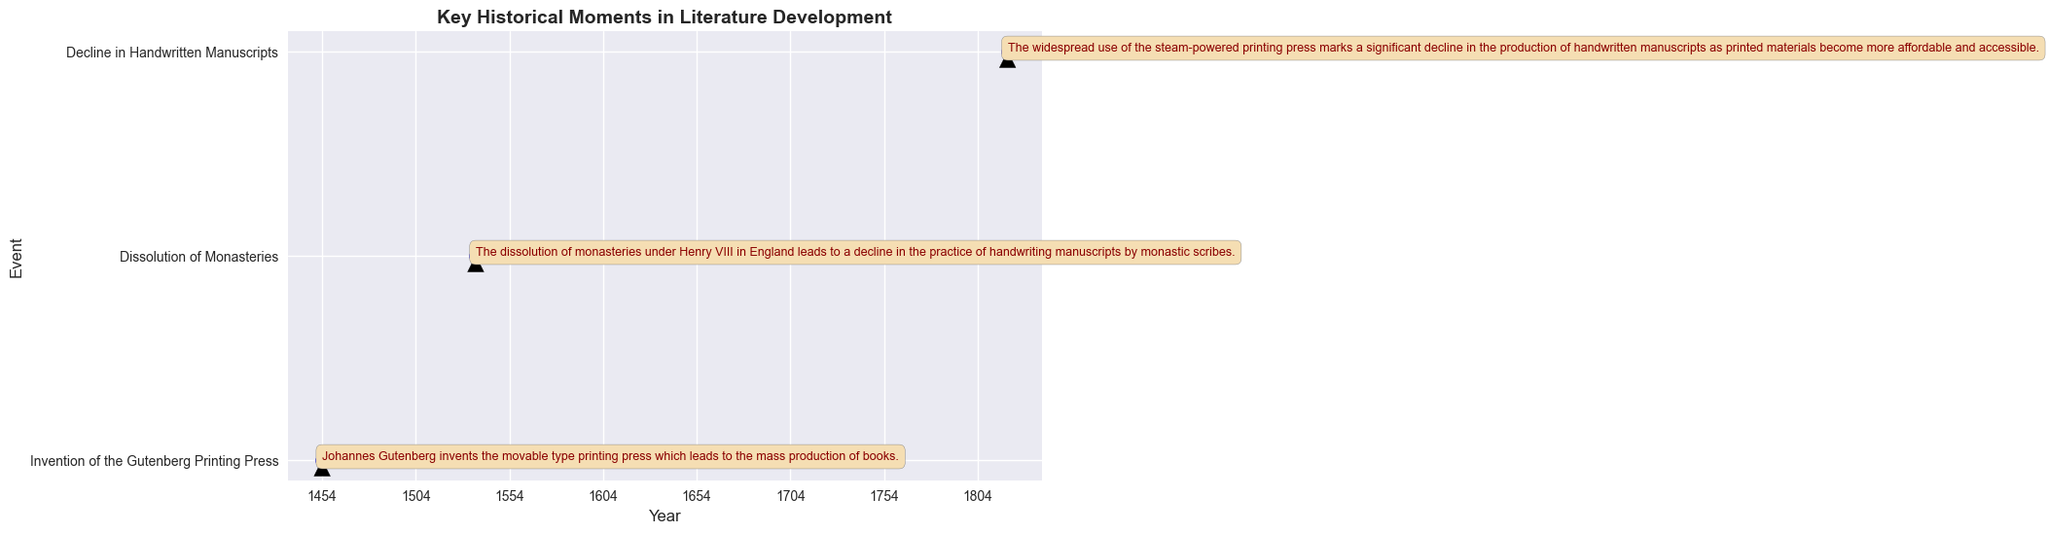What major invention in 1454 contributed to the mass production of books? In the figure, 1454 is marked with an event labeled "Invention of the Gutenberg Printing Press" which describes Johannes Gutenberg's creation of the movable type printing press for mass book production.
Answer: Gutenberg Printing Press Which event in 1536 led to a decline in handwriting manuscripts by monastic scribes? The plot shows that in 1536, the "Dissolution of Monasteries" under Henry VIII resulted in the decline of manuscript handwriting.
Answer: Dissolution of Monasteries How many years after the invention of the Gutenberg Printing Press did the dissolution of monasteries occur? The event "Invention of the Gutenberg Printing Press" is marked in 1454, and "Dissolution of Monasteries" in 1536. The difference between 1536 and 1454 is 1536 - 1454 = 82 years.
Answer: 82 years Which occurred first, the decline in handwritten manuscripts or the invention of the steam-powered printing press? The plot shows "Decline in Handwritten Manuscripts" marked in 1820, following the invention of the steam-powered printing press. Therefore, the invention of the steam-powered printing press happens first.
Answer: Invention of the steam-powered printing press Describe the relationship between the events in 1820 and 1536. In 1820, there was a "Decline in Handwritten Manuscripts" due to the steam-powered printing press, which followed the "Dissolution of Monasteries" in 1536. The dissolution led to an early decline in manuscript handwriting, further exacerbated by the widespread use of the steam-powered press in 1820.
Answer: Decline in Handwritten Manuscripts follows Dissolution of Monasteries How many significant events related to the development of literature are depicted in the plot? The plot indicates three specific events: "Invention of the Gutenberg Printing Press" in 1454, "Dissolution of Monasteries" in 1536, and "Decline in Handwritten Manuscripts" in 1820.
Answer: Three events Which event marked in the plot occurred in the 19th century? The figure shows the event "Decline in Handwritten Manuscripts" in 1820, falling within the 19th century.
Answer: Decline in Handwritten Manuscripts What visual element definitely ties the events to their descriptions in the plot? The plot uses arrows pointing from the event years to their detailed descriptions, ensuring clarity.
Answer: Arrows What historical development in literature occurred in the mid-15th century according to the plot? The plot marks "Invention of the Gutenberg Printing Press" in 1454, falling in the mid-15th century.
Answer: Invention of the Gutenberg Printing Press Compare the time span between the Dissolution of Monasteries and the Decline in Handwritten Manuscripts with the time between the Invention of the Gutenberg Printing Press and the Decline in Handwritten Manuscripts. Which span is longer? The Dissolution of Monasteries occurred in 1536, and the Decline in Handwritten Manuscripts in 1820, spanning 1820 - 1536 = 284 years. The Invention of the Gutenberg Printing Press occurred in 1454, and the Decline in Handwritten Manuscripts in 1820, spanning 1820 - 1454 = 366 years. Thus, the span from the Invention of the Gutenberg Printing Press to the Decline in Handwritten Manuscripts is longer.
Answer: Span from Gutenberg Printing Press to Decline 